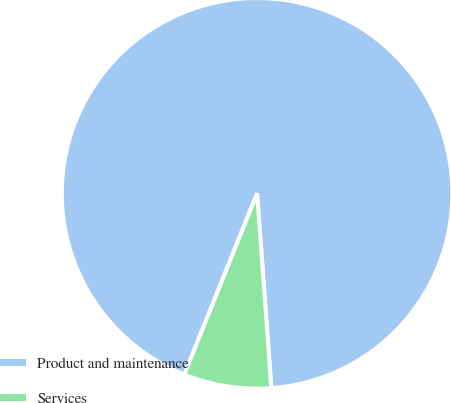<chart> <loc_0><loc_0><loc_500><loc_500><pie_chart><fcel>Product and maintenance<fcel>Services<nl><fcel>92.76%<fcel>7.24%<nl></chart> 